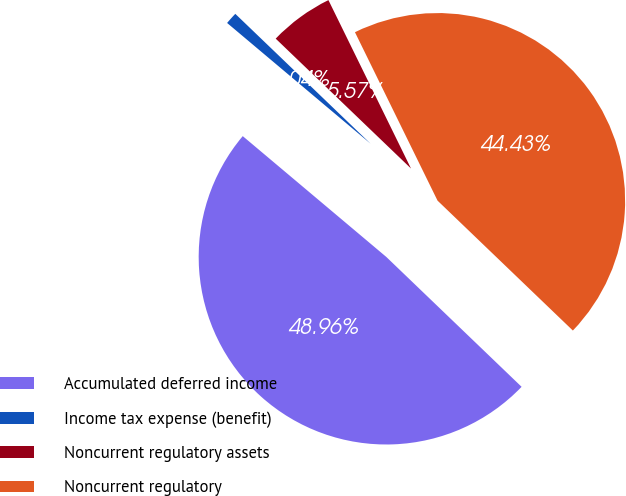Convert chart. <chart><loc_0><loc_0><loc_500><loc_500><pie_chart><fcel>Accumulated deferred income<fcel>Income tax expense (benefit)<fcel>Noncurrent regulatory assets<fcel>Noncurrent regulatory<nl><fcel>48.96%<fcel>1.04%<fcel>5.57%<fcel>44.43%<nl></chart> 